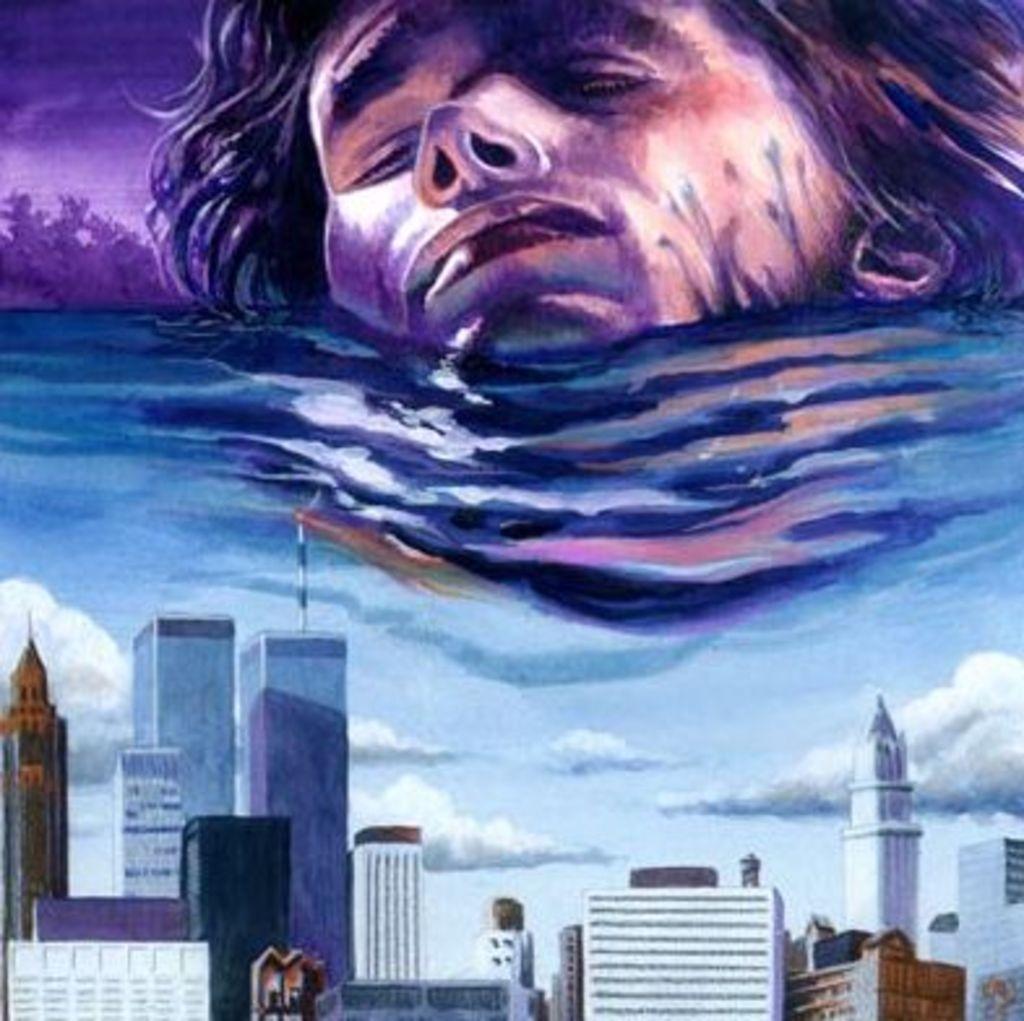In one or two sentences, can you explain what this image depicts? This is a painting. In this picture we can see a few buildings, clouds in the sky, water, other objects and the head of a person. 